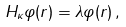Convert formula to latex. <formula><loc_0><loc_0><loc_500><loc_500>H _ { \kappa } \varphi ( r ) = \lambda \varphi ( r ) \, ,</formula> 